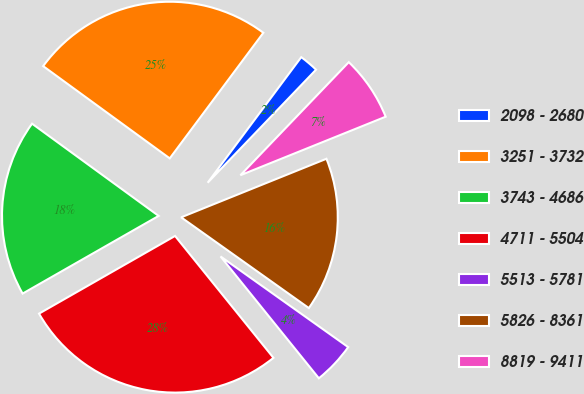Convert chart to OTSL. <chart><loc_0><loc_0><loc_500><loc_500><pie_chart><fcel>2098 - 2680<fcel>3251 - 3732<fcel>3743 - 4686<fcel>4711 - 5504<fcel>5513 - 5781<fcel>5826 - 8361<fcel>8819 - 9411<nl><fcel>1.97%<fcel>25.17%<fcel>18.28%<fcel>27.55%<fcel>4.36%<fcel>15.93%<fcel>6.74%<nl></chart> 